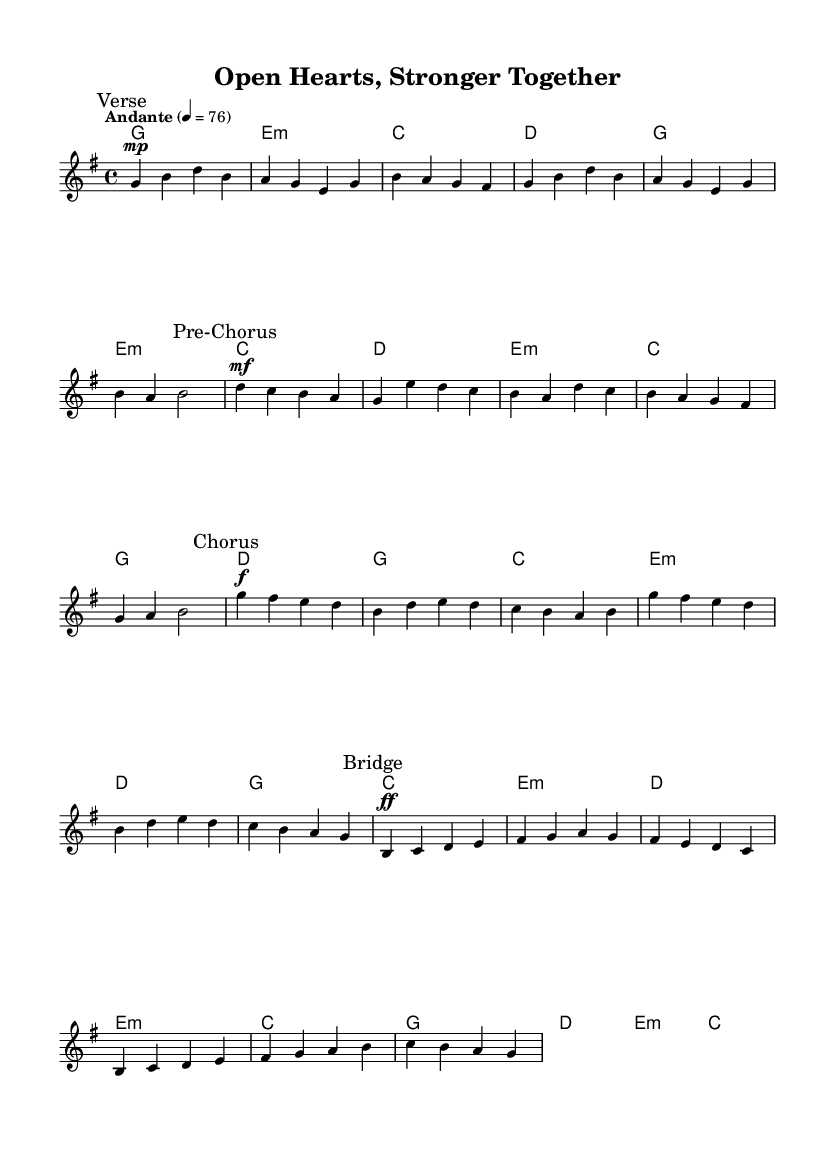What is the key signature of this music? The key signature shows one sharp, indicating that the piece is in G major.
Answer: G major What is the time signature of this music? The time signature appears as 4 over 4, meaning there are four beats in each measure.
Answer: 4/4 What is the tempo marking for this sheet? The tempo marking is indicated to be Andante, which suggests a moderate pace for the piece.
Answer: Andante How many measures are in the chorus section? The chorus section contains six measures as indicated by the notation.
Answer: Six What is the dynamic marking at the beginning of the verse? The verse starts with a mezzo-piano marking, suggesting a moderately soft volume.
Answer: Mezzo-piano How does the melody in the bridge compare dynamically to the verse? The bridge begins with a fortissimo marking, which is much louder than the mezzo-piano of the verse.
Answer: Fortissimo What is a common theme explored in the lyrics of K-Pop ballads like this? K-Pop ballads often explore themes of vulnerability, emotional experiences, and personal growth throughout their lyrics.
Answer: Vulnerability 